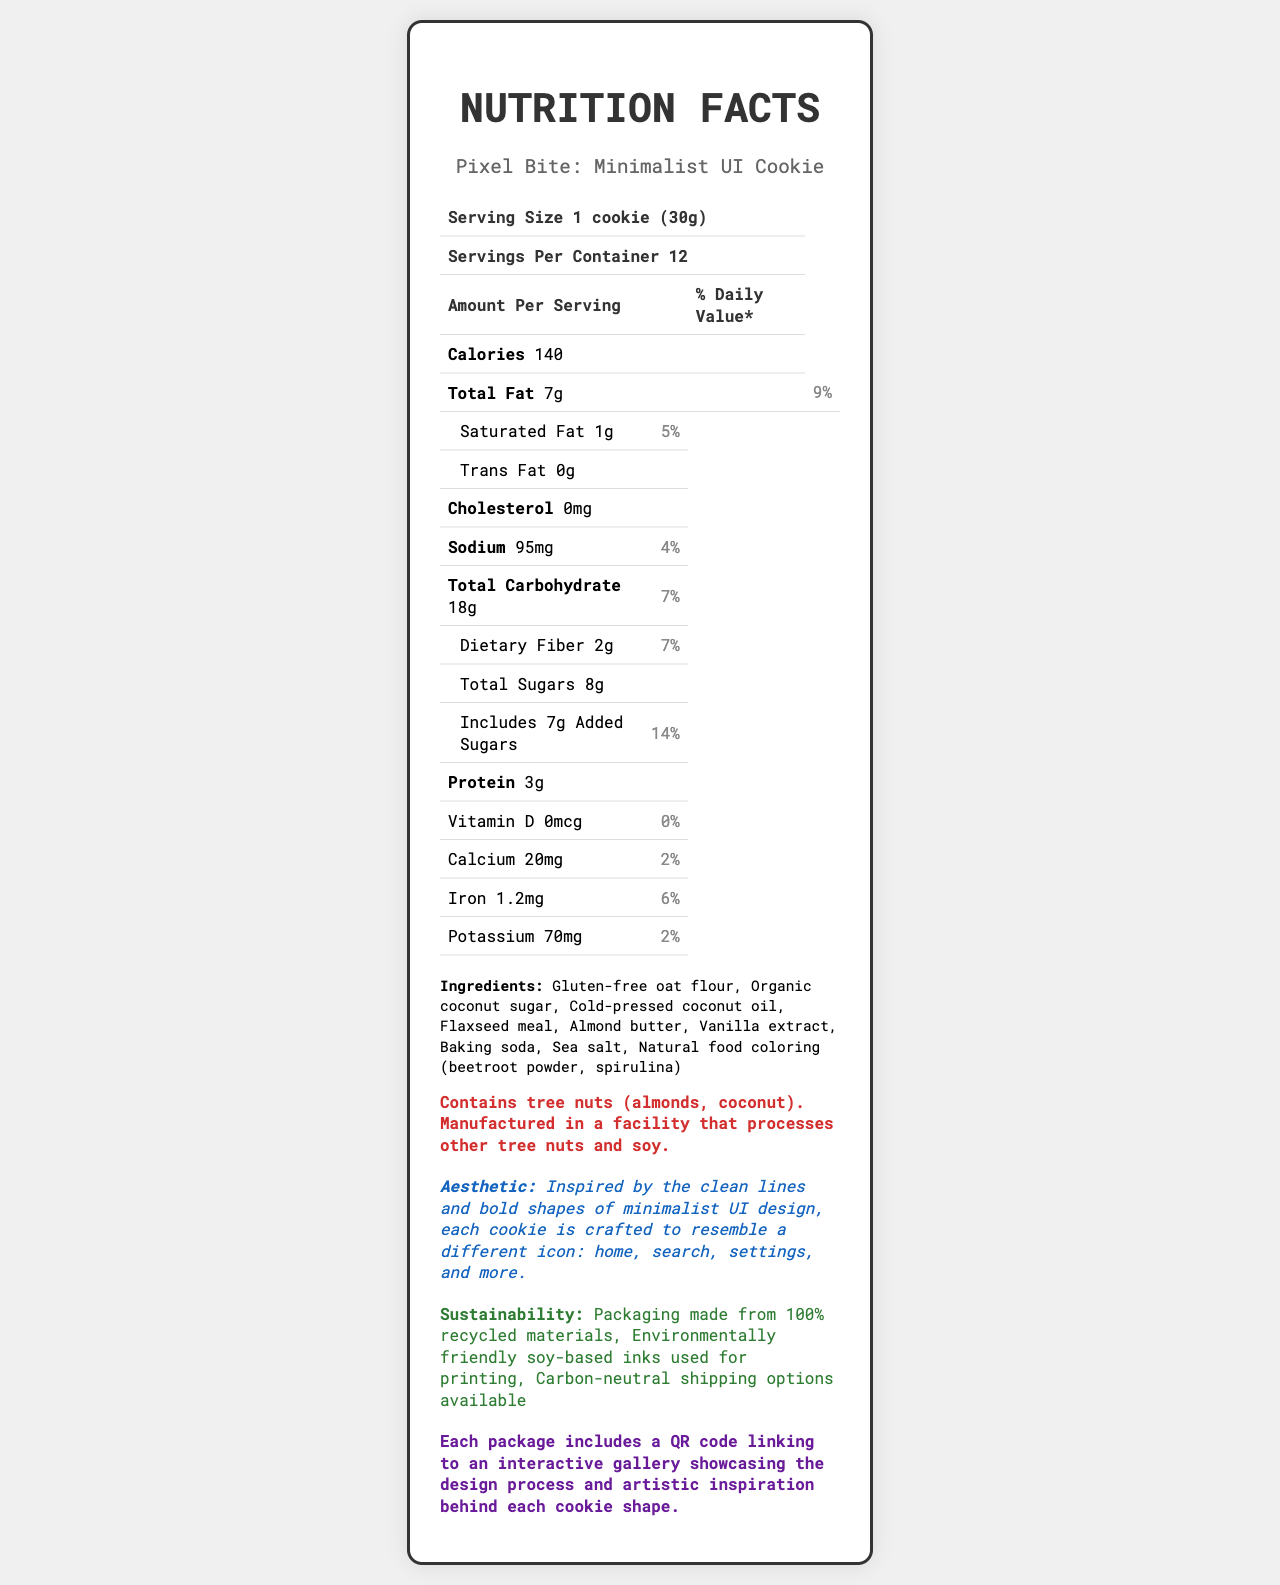what is the serving size of the cookie? The serving size is explicitly mentioned as "1 cookie (30g)" in the document.
Answer: 1 cookie (30g) how many servings are there per container? The document states that there are 12 servings per container.
Answer: 12 what is the total fat content per serving? The total fat content per serving is given as 7g in the nutritional information.
Answer: 7g what is the percentage of daily value for added sugars per serving? The document lists the daily value for added sugars as 14%.
Answer: 14% how much protein does one cookie contain? The protein content per cookie is listed as 3g.
Answer: 3g which ingredient provides the natural food coloring? A. Almond Butter B. Baking Soda C. Beetroot Powder and Spirulina D. Flaxseed Meal The ingredients section mentions "Natural food coloring (beetroot powder, spirulina)".
Answer: C what is the main design inspiration for these cookies? A. Abstract Art B. Modern Architecture C. Minimalist UI Design D. Organic Shapes The aesthetic description mentions that the cookies are inspired by "the clean lines and bold shapes of minimalist UI design".
Answer: C are these cookies vegan? The document mentions "vegan cookie" in the title, confirming that they are vegan.
Answer: Yes describe the sustainability features of this product The document lists that the packaging is made from recycled materials, uses soy-based inks, and offers carbon-neutral shipping.
Answer: Packaging made from 100% recycled materials, environmentally friendly soy-based inks used for printing, and carbon-neutral shipping options available who manufactured the cookies? The document does not provide information about the company or individual who manufactured the cookies.
Answer: Cannot be determined how many total carbohydrates are in one serving? The total carbohydrate content per serving is listed as 18g.
Answer: 18g how does the design of these cookies relate to software design? The document explains the aesthetic elements and design philosophy, highlighting the minimalist UI design principles incorporated into the cookie design.
Answer: The cookies are inspired by minimalist UI design principles such as monochromatic color schemes, geometric shapes, and pixel-perfect edges. Each cookie is crafted to resemble different UI icons like home, search, and settings. 